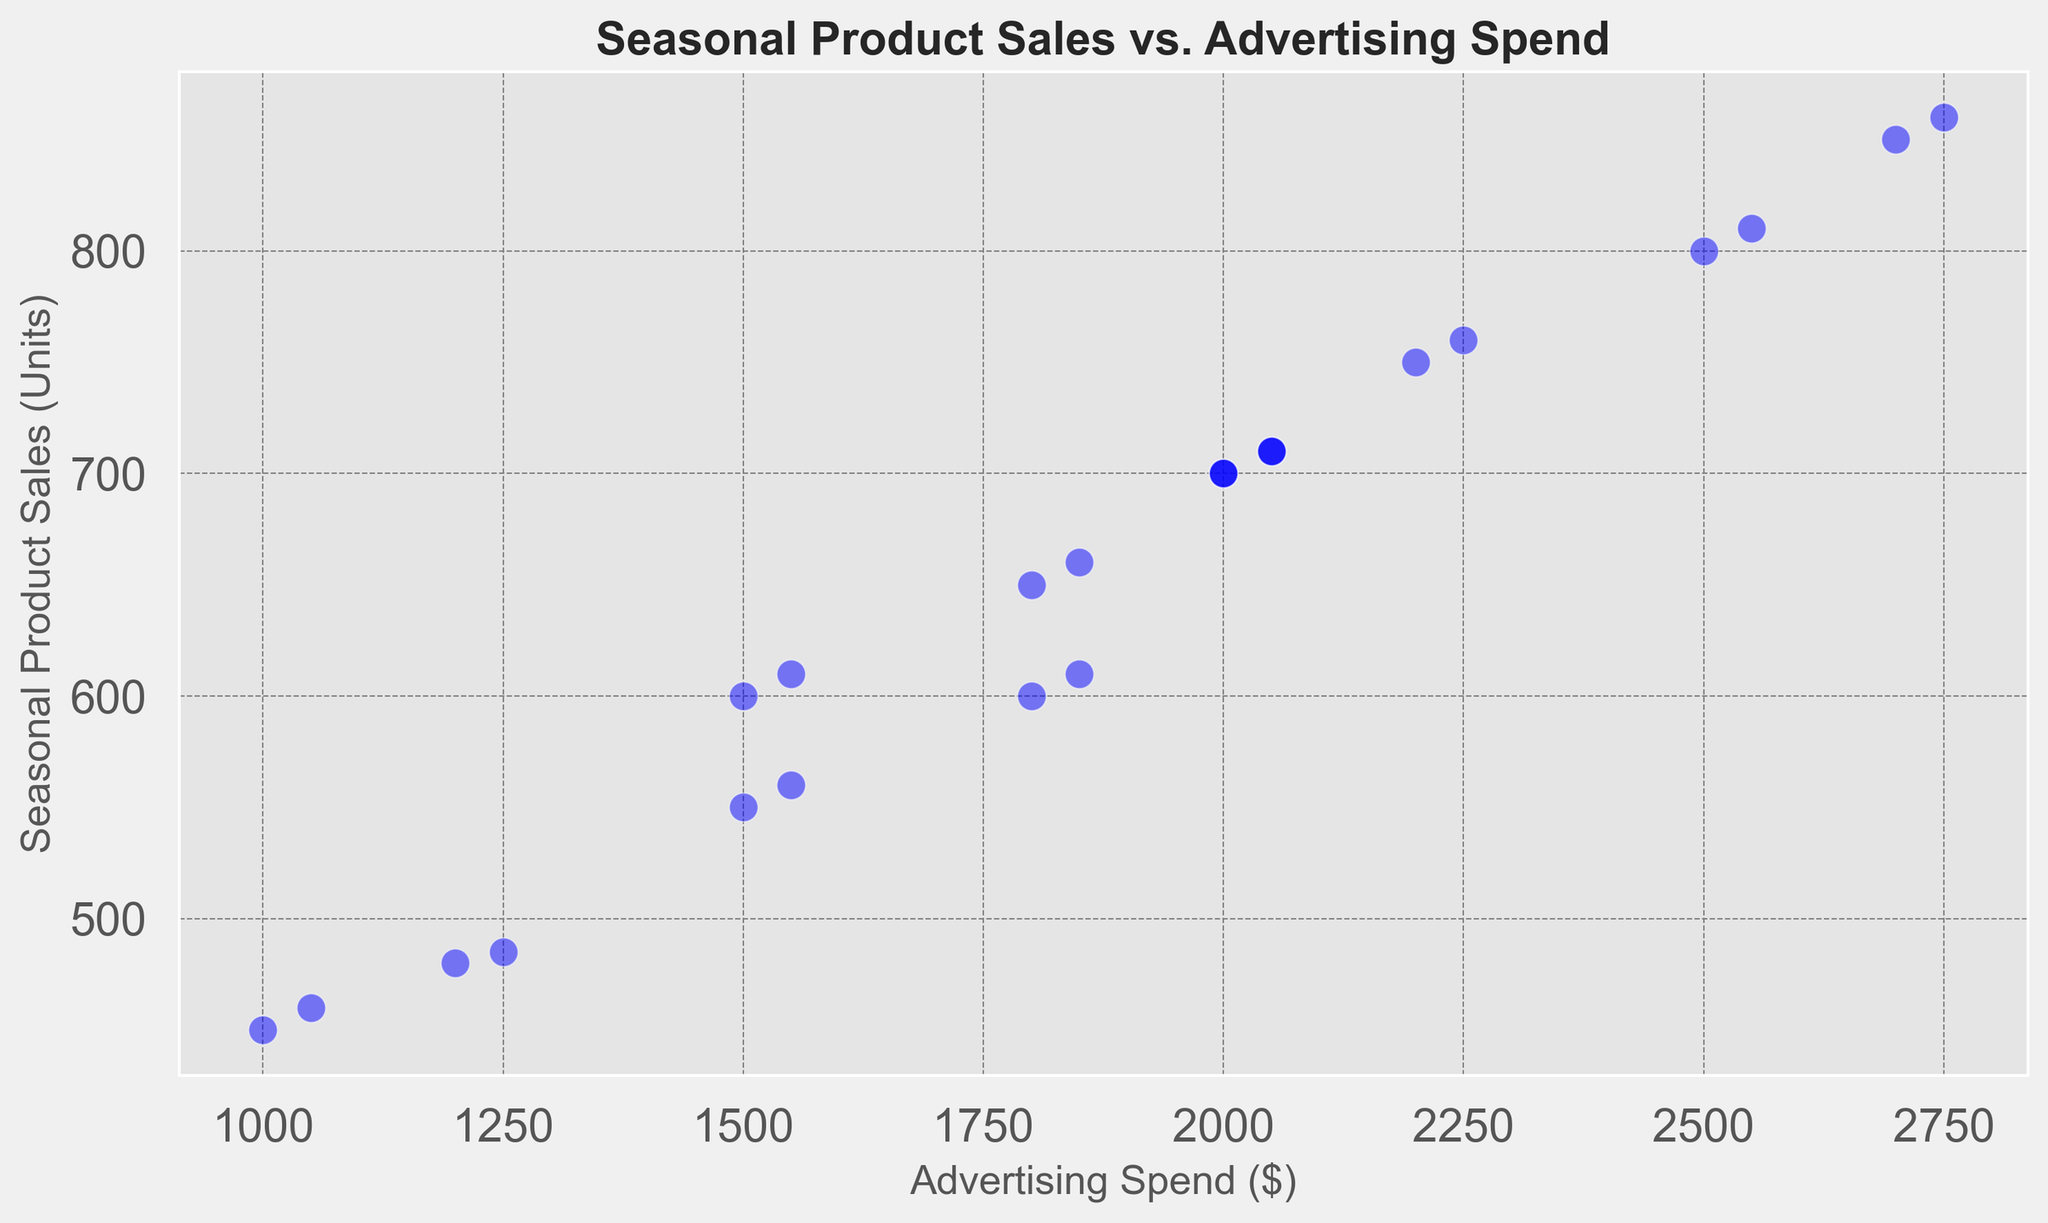What relationship can be observed between Advertising Spend and Seasonal Product Sales overall? From the scatter plot, as Advertising Spend increases, Seasonal Product Sales also tend to increase. This is indicated by the upward trend of the cluster of points, showing a positive correlation between the two variables.
Answer: Positive correlation Which month shows the maximum Advertising Spend and what are the corresponding sales in that month? The maximum Advertising Spend occurs in August at $2750. The corresponding Seasonal Product Sales for that month are 850 units. This can be seen as the highest point on the horizontal axis (Advertising Spend) which aligns with the sales value on the vertical axis.
Answer: August, 850 units Do the Seasonal Product Sales within July and August surpass 800 units, and how are they different? Yes, both July and August pass 800 units. In July, sales are 800 units, while in August, sales are 850 units. This difference can be noted as 850 - 800 = 50 units.
Answer: Yes, 50 units difference Is there any month where the Advertising Spend is $2000, and what are the Seasonal Product Sales for those months? Yes, Advertising Spend is $2000 in May, September, and December. The corresponding Seasonal Product Sales are 700 units for all these months. These points can be observed where the x-axis aligns with $2000 and the y-axis value is 700 units.
Answer: Yes, 700 units for May, September, and December In which months do the Seasonal Product Sales appear to dip after a continuous increase, as seen in the scatter plot? Seasonal Product Sales increase from January to August (from 450 to 850 units) and then dip in September (700 units) and October (650 units), before stabilizing. This trend is visible in the scatter plot where points rise and then fall slightly towards the end.
Answer: September and October Considering February and its corresponding Seasonal Product Sales across two years, what difference can be observed in their values? For February, the Seasonal Product Sales are 480 units in the first year and 485 units in the second year. The difference in sales is calculated as 485 - 480 = 5 units. This small change shows slight improvement year-over-year.
Answer: 5 units 